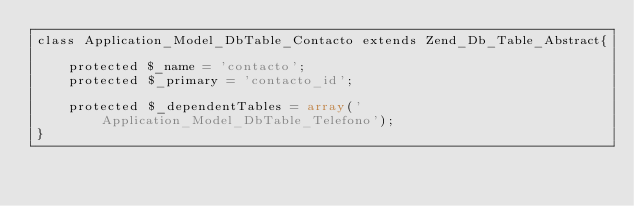<code> <loc_0><loc_0><loc_500><loc_500><_PHP_>class Application_Model_DbTable_Contacto extends Zend_Db_Table_Abstract{

    protected $_name = 'contacto';
    protected $_primary = 'contacto_id';

    protected $_dependentTables = array('Application_Model_DbTable_Telefono');
}

</code> 